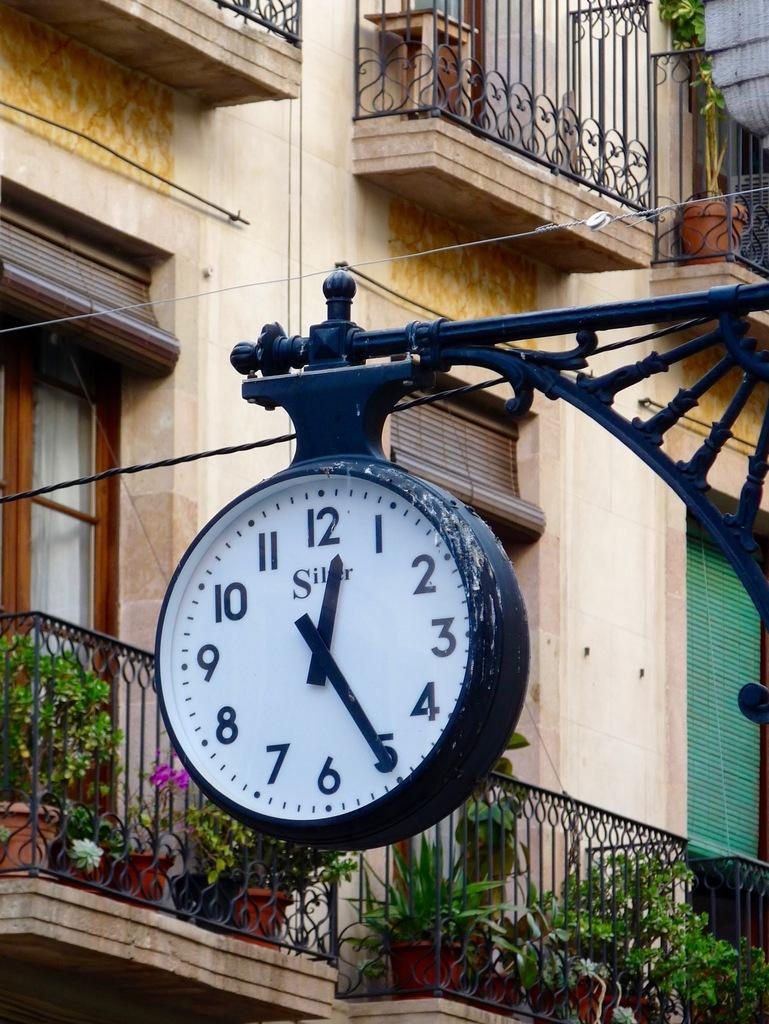Provide a one-sentence caption for the provided image. A clock with SILVER written on it points to the numbers 12 and 5. 